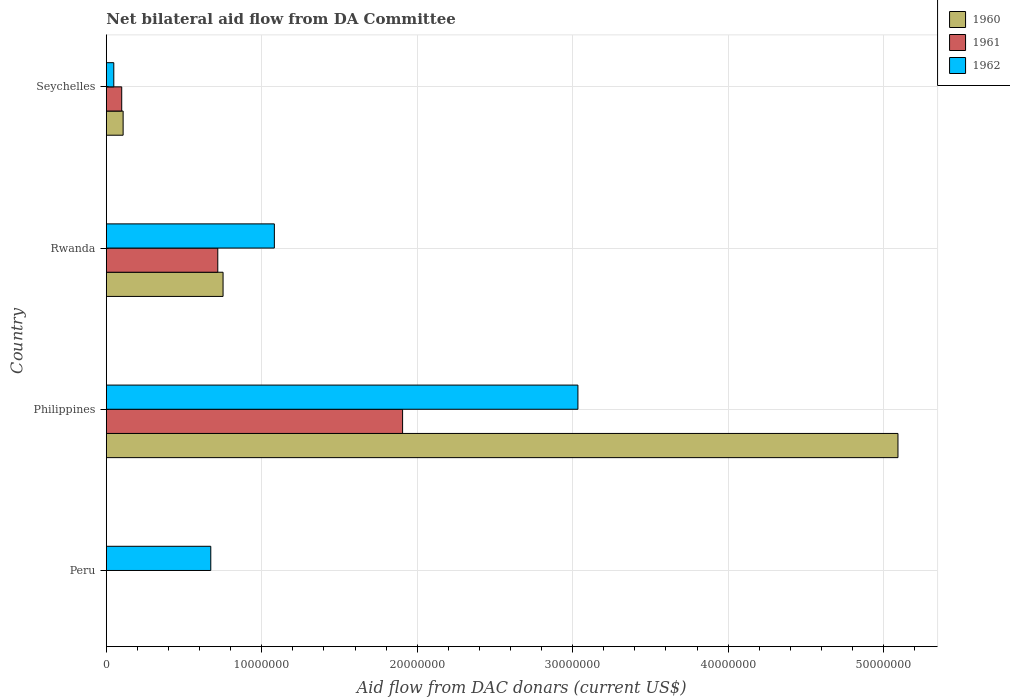How many different coloured bars are there?
Your response must be concise. 3. Are the number of bars per tick equal to the number of legend labels?
Make the answer very short. No. How many bars are there on the 2nd tick from the top?
Offer a terse response. 3. How many bars are there on the 1st tick from the bottom?
Keep it short and to the point. 1. What is the label of the 4th group of bars from the top?
Offer a terse response. Peru. In how many cases, is the number of bars for a given country not equal to the number of legend labels?
Keep it short and to the point. 1. Across all countries, what is the maximum aid flow in in 1961?
Keep it short and to the point. 1.91e+07. In which country was the aid flow in in 1961 maximum?
Offer a terse response. Philippines. What is the total aid flow in in 1960 in the graph?
Offer a very short reply. 5.95e+07. What is the difference between the aid flow in in 1962 in Rwanda and that in Seychelles?
Offer a terse response. 1.03e+07. What is the difference between the aid flow in in 1960 in Rwanda and the aid flow in in 1962 in Philippines?
Offer a very short reply. -2.28e+07. What is the average aid flow in in 1962 per country?
Provide a short and direct response. 1.21e+07. What is the difference between the aid flow in in 1962 and aid flow in in 1960 in Rwanda?
Your response must be concise. 3.30e+06. In how many countries, is the aid flow in in 1961 greater than 38000000 US$?
Your answer should be very brief. 0. What is the ratio of the aid flow in in 1960 in Philippines to that in Seychelles?
Your answer should be very brief. 47.16. Is the aid flow in in 1962 in Peru less than that in Seychelles?
Make the answer very short. No. Is the difference between the aid flow in in 1962 in Philippines and Seychelles greater than the difference between the aid flow in in 1960 in Philippines and Seychelles?
Your answer should be compact. No. What is the difference between the highest and the second highest aid flow in in 1962?
Provide a succinct answer. 1.95e+07. What is the difference between the highest and the lowest aid flow in in 1960?
Keep it short and to the point. 5.09e+07. In how many countries, is the aid flow in in 1960 greater than the average aid flow in in 1960 taken over all countries?
Ensure brevity in your answer.  1. How many bars are there?
Provide a short and direct response. 10. What is the difference between two consecutive major ticks on the X-axis?
Offer a very short reply. 1.00e+07. Does the graph contain grids?
Ensure brevity in your answer.  Yes. How many legend labels are there?
Your answer should be compact. 3. How are the legend labels stacked?
Offer a very short reply. Vertical. What is the title of the graph?
Make the answer very short. Net bilateral aid flow from DA Committee. Does "1965" appear as one of the legend labels in the graph?
Offer a very short reply. No. What is the label or title of the X-axis?
Ensure brevity in your answer.  Aid flow from DAC donars (current US$). What is the Aid flow from DAC donars (current US$) in 1960 in Peru?
Ensure brevity in your answer.  0. What is the Aid flow from DAC donars (current US$) of 1962 in Peru?
Make the answer very short. 6.72e+06. What is the Aid flow from DAC donars (current US$) in 1960 in Philippines?
Your answer should be very brief. 5.09e+07. What is the Aid flow from DAC donars (current US$) of 1961 in Philippines?
Ensure brevity in your answer.  1.91e+07. What is the Aid flow from DAC donars (current US$) in 1962 in Philippines?
Your answer should be very brief. 3.03e+07. What is the Aid flow from DAC donars (current US$) in 1960 in Rwanda?
Keep it short and to the point. 7.51e+06. What is the Aid flow from DAC donars (current US$) in 1961 in Rwanda?
Offer a terse response. 7.17e+06. What is the Aid flow from DAC donars (current US$) of 1962 in Rwanda?
Make the answer very short. 1.08e+07. What is the Aid flow from DAC donars (current US$) of 1960 in Seychelles?
Give a very brief answer. 1.08e+06. What is the Aid flow from DAC donars (current US$) of 1961 in Seychelles?
Offer a very short reply. 9.90e+05. What is the Aid flow from DAC donars (current US$) of 1962 in Seychelles?
Give a very brief answer. 4.80e+05. Across all countries, what is the maximum Aid flow from DAC donars (current US$) of 1960?
Make the answer very short. 5.09e+07. Across all countries, what is the maximum Aid flow from DAC donars (current US$) of 1961?
Offer a terse response. 1.91e+07. Across all countries, what is the maximum Aid flow from DAC donars (current US$) of 1962?
Provide a succinct answer. 3.03e+07. Across all countries, what is the minimum Aid flow from DAC donars (current US$) in 1961?
Ensure brevity in your answer.  0. What is the total Aid flow from DAC donars (current US$) in 1960 in the graph?
Provide a short and direct response. 5.95e+07. What is the total Aid flow from DAC donars (current US$) in 1961 in the graph?
Ensure brevity in your answer.  2.72e+07. What is the total Aid flow from DAC donars (current US$) of 1962 in the graph?
Provide a short and direct response. 4.84e+07. What is the difference between the Aid flow from DAC donars (current US$) of 1962 in Peru and that in Philippines?
Ensure brevity in your answer.  -2.36e+07. What is the difference between the Aid flow from DAC donars (current US$) of 1962 in Peru and that in Rwanda?
Provide a succinct answer. -4.09e+06. What is the difference between the Aid flow from DAC donars (current US$) in 1962 in Peru and that in Seychelles?
Provide a short and direct response. 6.24e+06. What is the difference between the Aid flow from DAC donars (current US$) in 1960 in Philippines and that in Rwanda?
Your response must be concise. 4.34e+07. What is the difference between the Aid flow from DAC donars (current US$) of 1961 in Philippines and that in Rwanda?
Your answer should be compact. 1.19e+07. What is the difference between the Aid flow from DAC donars (current US$) in 1962 in Philippines and that in Rwanda?
Offer a very short reply. 1.95e+07. What is the difference between the Aid flow from DAC donars (current US$) in 1960 in Philippines and that in Seychelles?
Keep it short and to the point. 4.98e+07. What is the difference between the Aid flow from DAC donars (current US$) of 1961 in Philippines and that in Seychelles?
Offer a very short reply. 1.81e+07. What is the difference between the Aid flow from DAC donars (current US$) in 1962 in Philippines and that in Seychelles?
Make the answer very short. 2.99e+07. What is the difference between the Aid flow from DAC donars (current US$) in 1960 in Rwanda and that in Seychelles?
Make the answer very short. 6.43e+06. What is the difference between the Aid flow from DAC donars (current US$) of 1961 in Rwanda and that in Seychelles?
Your response must be concise. 6.18e+06. What is the difference between the Aid flow from DAC donars (current US$) of 1962 in Rwanda and that in Seychelles?
Keep it short and to the point. 1.03e+07. What is the difference between the Aid flow from DAC donars (current US$) of 1960 in Philippines and the Aid flow from DAC donars (current US$) of 1961 in Rwanda?
Offer a very short reply. 4.38e+07. What is the difference between the Aid flow from DAC donars (current US$) in 1960 in Philippines and the Aid flow from DAC donars (current US$) in 1962 in Rwanda?
Your answer should be very brief. 4.01e+07. What is the difference between the Aid flow from DAC donars (current US$) in 1961 in Philippines and the Aid flow from DAC donars (current US$) in 1962 in Rwanda?
Give a very brief answer. 8.25e+06. What is the difference between the Aid flow from DAC donars (current US$) of 1960 in Philippines and the Aid flow from DAC donars (current US$) of 1961 in Seychelles?
Your answer should be compact. 4.99e+07. What is the difference between the Aid flow from DAC donars (current US$) of 1960 in Philippines and the Aid flow from DAC donars (current US$) of 1962 in Seychelles?
Make the answer very short. 5.04e+07. What is the difference between the Aid flow from DAC donars (current US$) of 1961 in Philippines and the Aid flow from DAC donars (current US$) of 1962 in Seychelles?
Keep it short and to the point. 1.86e+07. What is the difference between the Aid flow from DAC donars (current US$) in 1960 in Rwanda and the Aid flow from DAC donars (current US$) in 1961 in Seychelles?
Offer a very short reply. 6.52e+06. What is the difference between the Aid flow from DAC donars (current US$) in 1960 in Rwanda and the Aid flow from DAC donars (current US$) in 1962 in Seychelles?
Provide a succinct answer. 7.03e+06. What is the difference between the Aid flow from DAC donars (current US$) of 1961 in Rwanda and the Aid flow from DAC donars (current US$) of 1962 in Seychelles?
Ensure brevity in your answer.  6.69e+06. What is the average Aid flow from DAC donars (current US$) in 1960 per country?
Your answer should be compact. 1.49e+07. What is the average Aid flow from DAC donars (current US$) in 1961 per country?
Give a very brief answer. 6.80e+06. What is the average Aid flow from DAC donars (current US$) in 1962 per country?
Your answer should be very brief. 1.21e+07. What is the difference between the Aid flow from DAC donars (current US$) of 1960 and Aid flow from DAC donars (current US$) of 1961 in Philippines?
Give a very brief answer. 3.19e+07. What is the difference between the Aid flow from DAC donars (current US$) in 1960 and Aid flow from DAC donars (current US$) in 1962 in Philippines?
Offer a terse response. 2.06e+07. What is the difference between the Aid flow from DAC donars (current US$) in 1961 and Aid flow from DAC donars (current US$) in 1962 in Philippines?
Keep it short and to the point. -1.13e+07. What is the difference between the Aid flow from DAC donars (current US$) in 1960 and Aid flow from DAC donars (current US$) in 1962 in Rwanda?
Ensure brevity in your answer.  -3.30e+06. What is the difference between the Aid flow from DAC donars (current US$) in 1961 and Aid flow from DAC donars (current US$) in 1962 in Rwanda?
Your answer should be compact. -3.64e+06. What is the difference between the Aid flow from DAC donars (current US$) in 1960 and Aid flow from DAC donars (current US$) in 1961 in Seychelles?
Offer a very short reply. 9.00e+04. What is the difference between the Aid flow from DAC donars (current US$) in 1961 and Aid flow from DAC donars (current US$) in 1962 in Seychelles?
Make the answer very short. 5.10e+05. What is the ratio of the Aid flow from DAC donars (current US$) in 1962 in Peru to that in Philippines?
Provide a succinct answer. 0.22. What is the ratio of the Aid flow from DAC donars (current US$) in 1962 in Peru to that in Rwanda?
Your answer should be very brief. 0.62. What is the ratio of the Aid flow from DAC donars (current US$) of 1962 in Peru to that in Seychelles?
Ensure brevity in your answer.  14. What is the ratio of the Aid flow from DAC donars (current US$) of 1960 in Philippines to that in Rwanda?
Offer a terse response. 6.78. What is the ratio of the Aid flow from DAC donars (current US$) in 1961 in Philippines to that in Rwanda?
Ensure brevity in your answer.  2.66. What is the ratio of the Aid flow from DAC donars (current US$) of 1962 in Philippines to that in Rwanda?
Give a very brief answer. 2.81. What is the ratio of the Aid flow from DAC donars (current US$) of 1960 in Philippines to that in Seychelles?
Ensure brevity in your answer.  47.16. What is the ratio of the Aid flow from DAC donars (current US$) in 1961 in Philippines to that in Seychelles?
Offer a terse response. 19.25. What is the ratio of the Aid flow from DAC donars (current US$) of 1962 in Philippines to that in Seychelles?
Provide a succinct answer. 63.21. What is the ratio of the Aid flow from DAC donars (current US$) of 1960 in Rwanda to that in Seychelles?
Your answer should be very brief. 6.95. What is the ratio of the Aid flow from DAC donars (current US$) in 1961 in Rwanda to that in Seychelles?
Offer a terse response. 7.24. What is the ratio of the Aid flow from DAC donars (current US$) of 1962 in Rwanda to that in Seychelles?
Provide a short and direct response. 22.52. What is the difference between the highest and the second highest Aid flow from DAC donars (current US$) in 1960?
Provide a short and direct response. 4.34e+07. What is the difference between the highest and the second highest Aid flow from DAC donars (current US$) in 1961?
Your answer should be compact. 1.19e+07. What is the difference between the highest and the second highest Aid flow from DAC donars (current US$) of 1962?
Your response must be concise. 1.95e+07. What is the difference between the highest and the lowest Aid flow from DAC donars (current US$) in 1960?
Offer a very short reply. 5.09e+07. What is the difference between the highest and the lowest Aid flow from DAC donars (current US$) of 1961?
Offer a very short reply. 1.91e+07. What is the difference between the highest and the lowest Aid flow from DAC donars (current US$) in 1962?
Ensure brevity in your answer.  2.99e+07. 